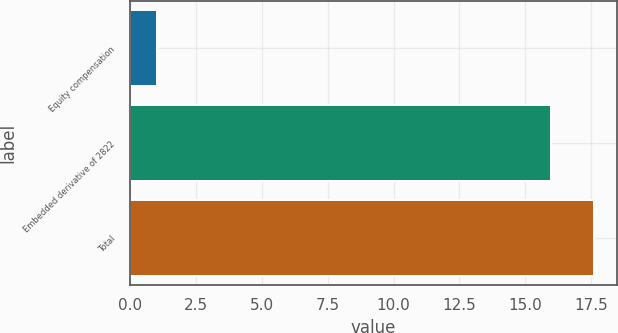<chart> <loc_0><loc_0><loc_500><loc_500><bar_chart><fcel>Equity compensation<fcel>Embedded derivative of 2822<fcel>Total<nl><fcel>1<fcel>16<fcel>17.6<nl></chart> 